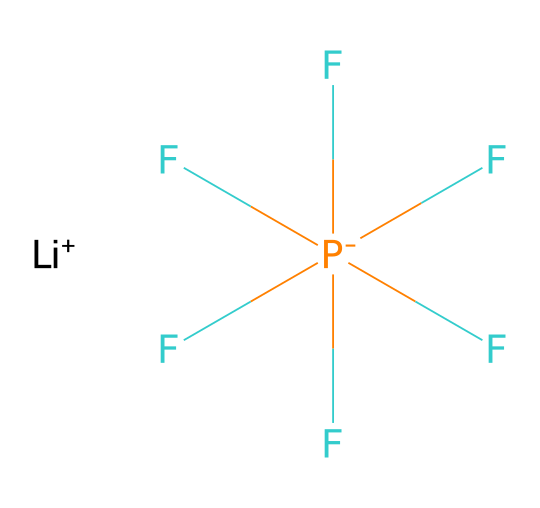What is the primary cation present in this chemical structure? The SMILES representation indicates the presence of a lithium ion denoted by [Li+]. There are no other cations present in this chemical structure.
Answer: lithium ion How many fluorine atoms are present in the structure? The SMILES representation shows five fluorine atoms attached to the phosphorus atom. Each 'F' in the structure represents one fluorine atom.
Answer: five What type of bond connects the lithium ion and the phosphorous-containing group? In the chemical structure, the lithium ion [Li+] is ionically bonded to the phosphorus-containing species F[P-](F)(F)(F)(F)F. The charge on [Li+] and the phosphorus species indicate an ionic bond.
Answer: ionic bond What is the oxidation state of phosphorus in this compound? To determine the oxidation state, phosphorus (P) must balance the five negative charges from fluorine (each contributing -1) and the one positive charge from lithium (+1). Thus, the oxidation state of phosphorus is +5.
Answer: +5 Is this chemical compound polar or nonpolar? Considering the structure consists of a phosphorus core with multiple fluorine atoms, which are highly electronegative, there is a significant dipole moment due to the uneven distribution of electron density. Thus, this compound is polar.
Answer: polar What is the primary type of this chemical compound? Given the elements within the structure, along with the ionic characteristics, this compound can be classified as an inorganic salt, as it is formed from the reaction of an acid with a base.
Answer: inorganic salt 